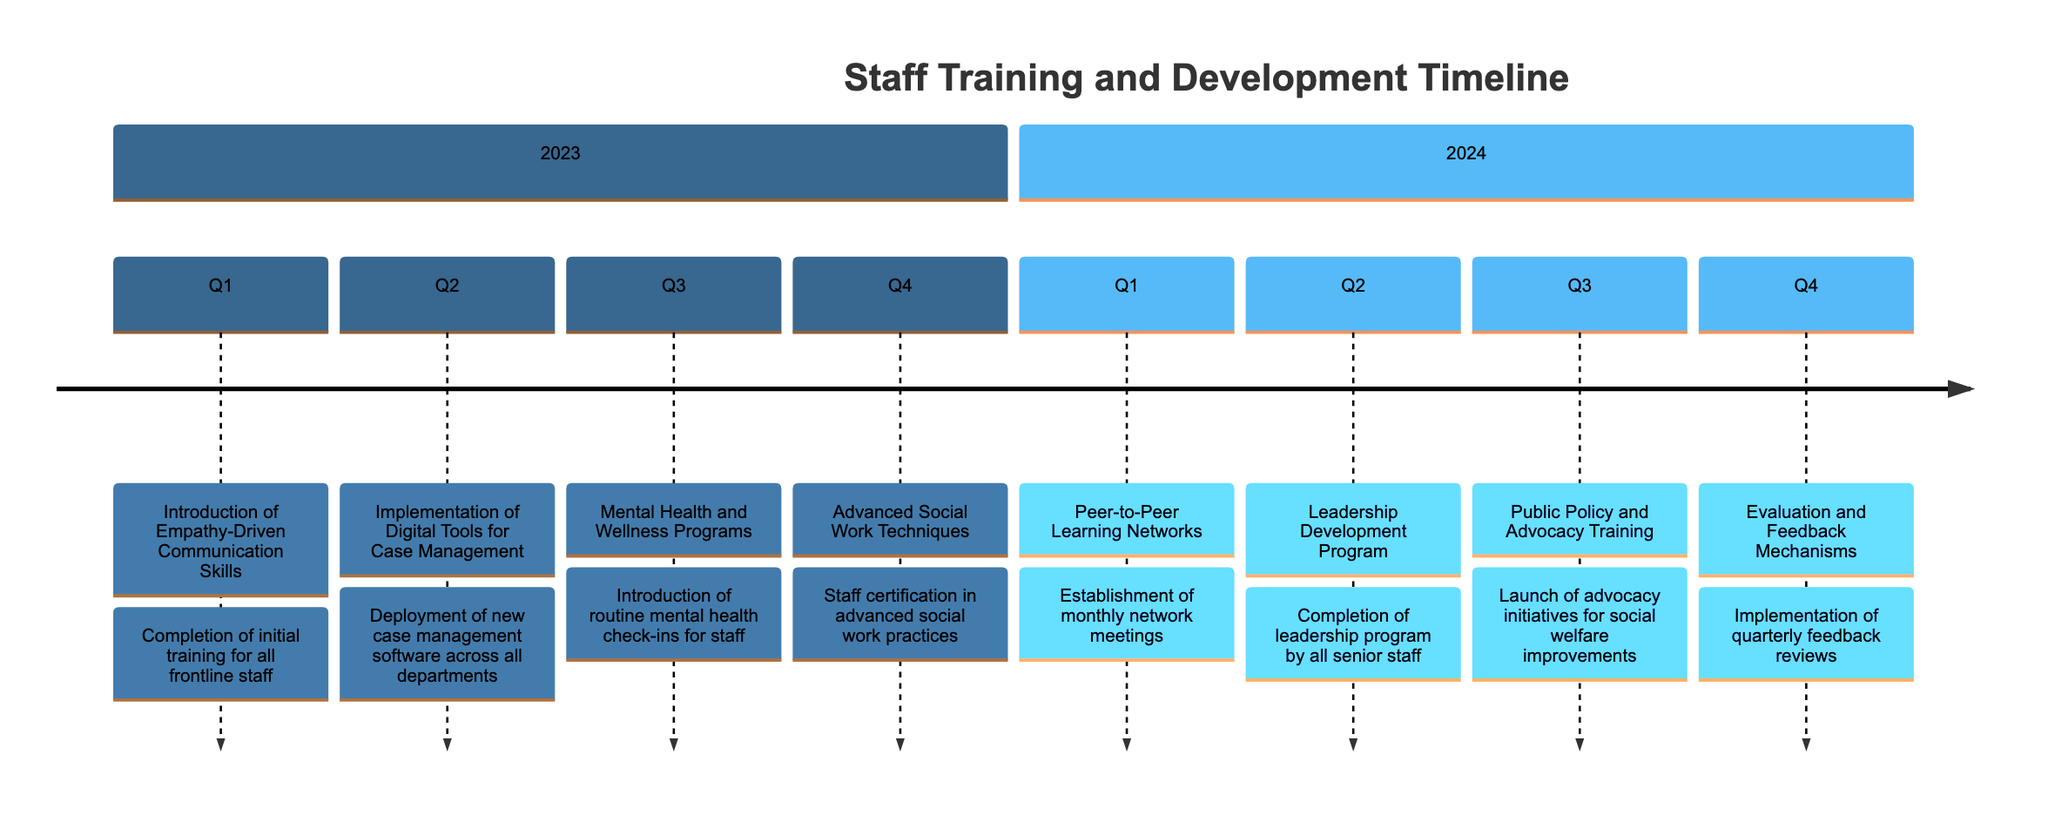What is the training initiative for Q1 2023? Referring to the timeline, Q1 of 2023 specifically mentions the initiative titled "Introduction of Empathy-Driven Communication Skills."
Answer: Introduction of Empathy-Driven Communication Skills How many training initiatives are scheduled for 2023? By reviewing the timeline, there are four distinct training initiatives scheduled for the year 2023, one for each quarter.
Answer: 4 What milestone is associated with the Q3 2024 initiative? The initiative for Q3 2024 is "Public Policy and Advocacy Training," and its associated milestone is the "Launch of advocacy initiatives for social welfare improvements."
Answer: Launch of advocacy initiatives for social welfare improvements Which quarter has a focus on staff mental health? The timeline indicates that Q3 2023 is dedicated to "Mental Health and Wellness Programs," which focuses on staff well-being.
Answer: Q3 2023 What is the last initiative planned for 2024? The final initiative planned for 2024 is "Evaluation and Feedback Mechanisms," scheduled for Q4.
Answer: Evaluation and Feedback Mechanisms What type of program is scheduled for Q2 2024? The timeline lists "Leadership Development Program" as the initiative for Q2 2024, focused on leadership skills for senior staff.
Answer: Leadership Development Program Which organization is involved in training for Digital Tools for Case Management? The workshops for this initiative are conducted by "Tech for Good," as outlined in the timeline for Q2 2023.
Answer: Tech for Good How often will Peer-to-Peer Learning Network meetings occur? According to the Q1 2024 initiative, monthly network meetings are established as part of the "Peer-to-Peer Learning Networks."
Answer: Monthly 